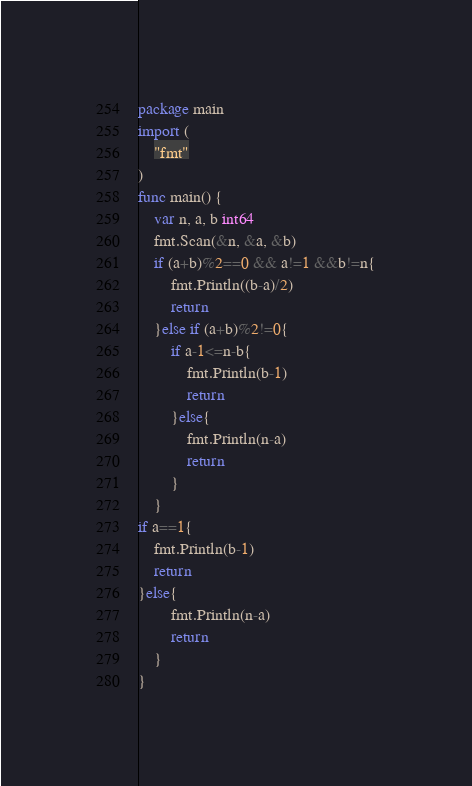Convert code to text. <code><loc_0><loc_0><loc_500><loc_500><_Go_>package main
import (
	"fmt"
)
func main() {
	var n, a, b int64
	fmt.Scan(&n, &a, &b)
	if (a+b)%2==0 && a!=1 &&b!=n{
		fmt.Println((b-a)/2)
		return
	}else if (a+b)%2!=0{
		if a-1<=n-b{
			fmt.Println(b-1)
			return
		}else{
			fmt.Println(n-a)
			return
		}
	}
if a==1{
	fmt.Println(b-1)
	return
}else{
		fmt.Println(n-a)
		return
	}
}
</code> 